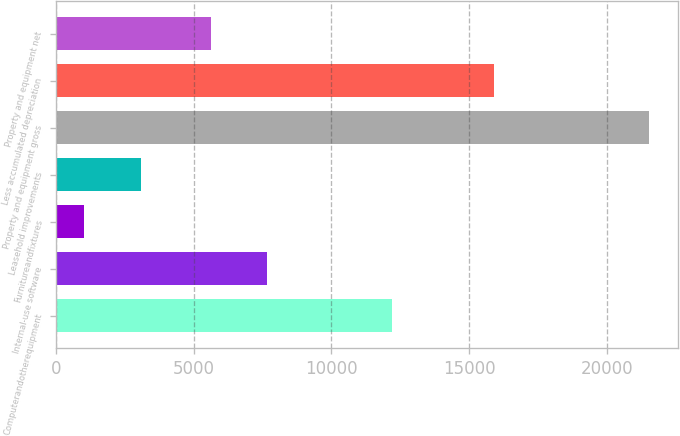Convert chart to OTSL. <chart><loc_0><loc_0><loc_500><loc_500><bar_chart><fcel>Computerandotherequipment<fcel>Internal-use software<fcel>Furnitureandfixtures<fcel>Leasehold improvements<fcel>Property and equipment gross<fcel>Less accumulated depreciation<fcel>Property and equipment net<nl><fcel>12197<fcel>7669.3<fcel>1031<fcel>3080.3<fcel>21524<fcel>15904<fcel>5620<nl></chart> 